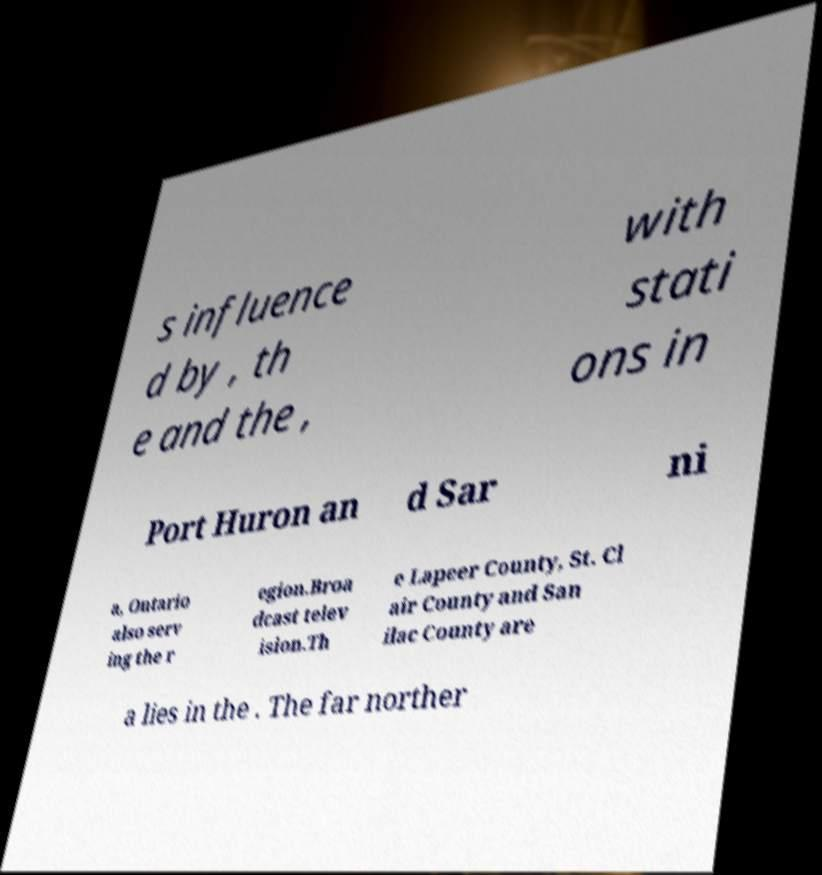Could you extract and type out the text from this image? s influence d by , th e and the , with stati ons in Port Huron an d Sar ni a, Ontario also serv ing the r egion.Broa dcast telev ision.Th e Lapeer County, St. Cl air County and San ilac County are a lies in the . The far norther 